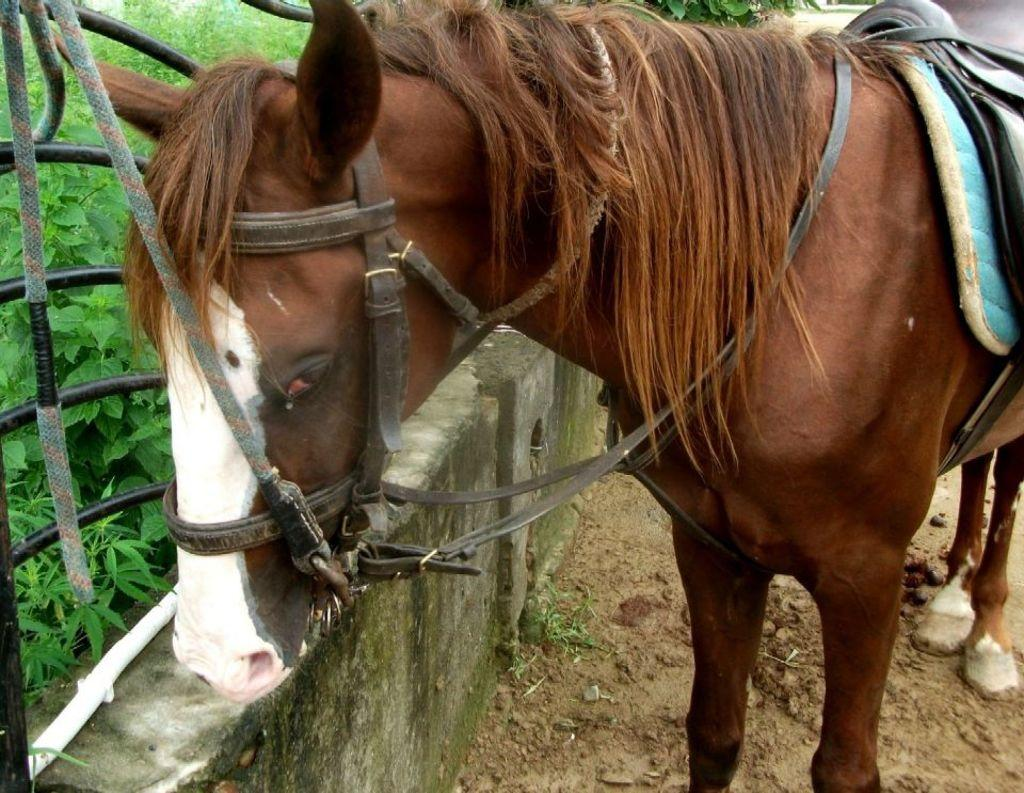What animal can be seen on the right side of the image? There is a horse on the ground on the right side of the image. What structures are present on the left side of the image? There is a wall and fencing on the left side of the image. What type of vegetation is visible in the background of the image? There are many plants visible in the background of the image. What type of education is the horse receiving in the image? There is no indication in the image that the horse is receiving any education. 